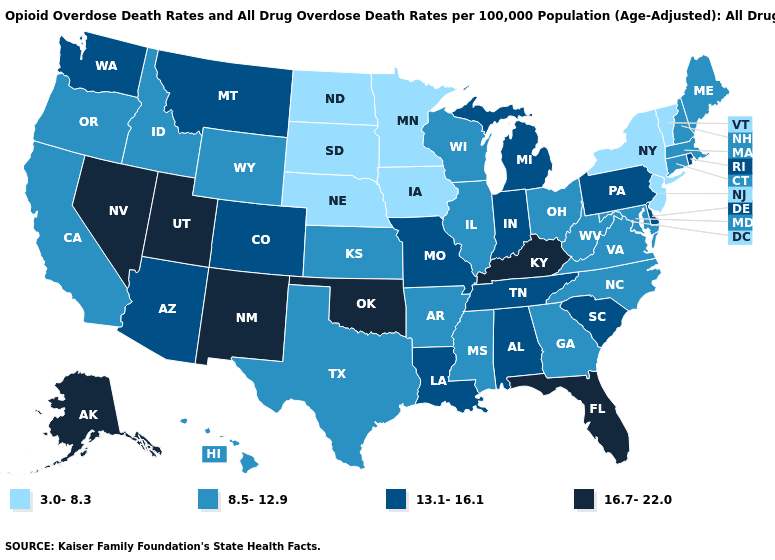What is the value of Minnesota?
Concise answer only. 3.0-8.3. Name the states that have a value in the range 13.1-16.1?
Answer briefly. Alabama, Arizona, Colorado, Delaware, Indiana, Louisiana, Michigan, Missouri, Montana, Pennsylvania, Rhode Island, South Carolina, Tennessee, Washington. What is the value of Hawaii?
Be succinct. 8.5-12.9. How many symbols are there in the legend?
Be succinct. 4. Does Michigan have the highest value in the MidWest?
Short answer required. Yes. Name the states that have a value in the range 13.1-16.1?
Answer briefly. Alabama, Arizona, Colorado, Delaware, Indiana, Louisiana, Michigan, Missouri, Montana, Pennsylvania, Rhode Island, South Carolina, Tennessee, Washington. What is the value of New Hampshire?
Keep it brief. 8.5-12.9. What is the lowest value in states that border Pennsylvania?
Answer briefly. 3.0-8.3. Is the legend a continuous bar?
Write a very short answer. No. Does Washington have the same value as Arkansas?
Be succinct. No. What is the value of New York?
Concise answer only. 3.0-8.3. Does Colorado have a higher value than Arkansas?
Quick response, please. Yes. Name the states that have a value in the range 16.7-22.0?
Answer briefly. Alaska, Florida, Kentucky, Nevada, New Mexico, Oklahoma, Utah. Which states hav the highest value in the South?
Keep it brief. Florida, Kentucky, Oklahoma. Does Arizona have a lower value than Indiana?
Keep it brief. No. 